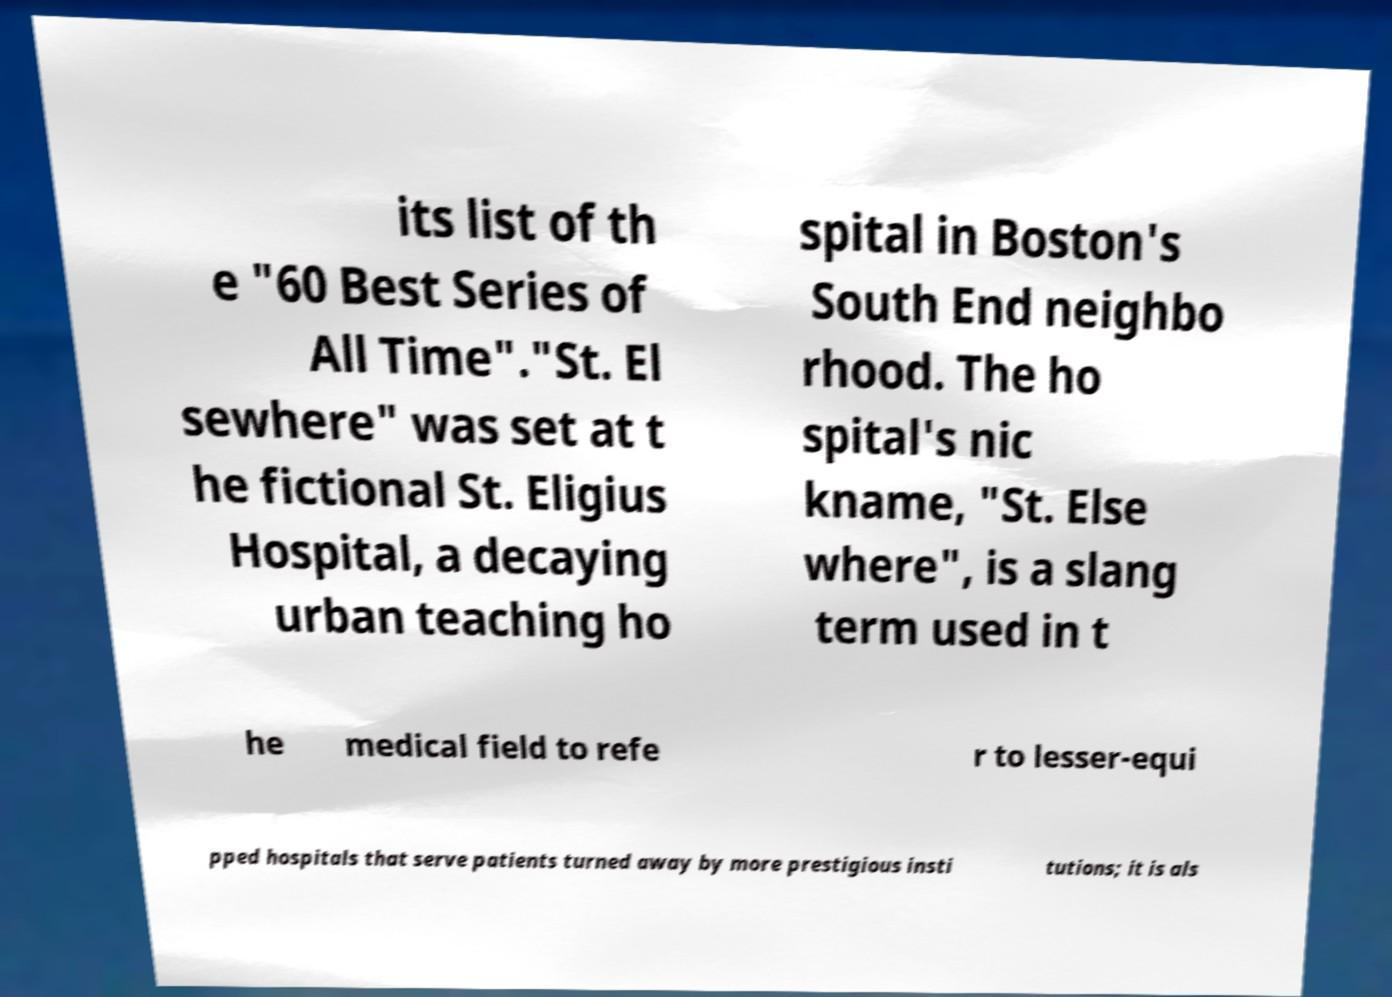What messages or text are displayed in this image? I need them in a readable, typed format. its list of th e "60 Best Series of All Time"."St. El sewhere" was set at t he fictional St. Eligius Hospital, a decaying urban teaching ho spital in Boston's South End neighbo rhood. The ho spital's nic kname, "St. Else where", is a slang term used in t he medical field to refe r to lesser-equi pped hospitals that serve patients turned away by more prestigious insti tutions; it is als 